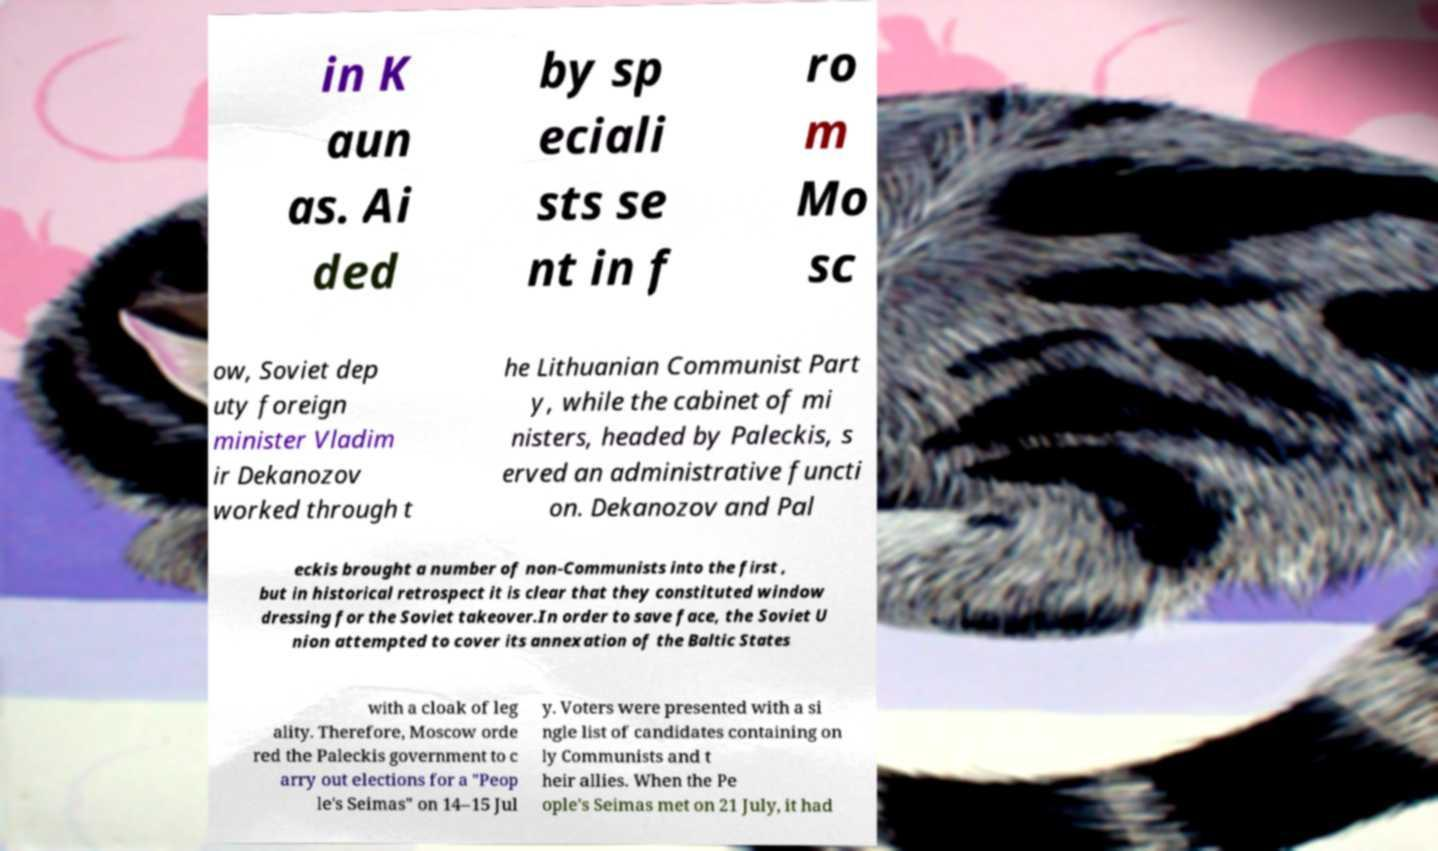I need the written content from this picture converted into text. Can you do that? in K aun as. Ai ded by sp eciali sts se nt in f ro m Mo sc ow, Soviet dep uty foreign minister Vladim ir Dekanozov worked through t he Lithuanian Communist Part y, while the cabinet of mi nisters, headed by Paleckis, s erved an administrative functi on. Dekanozov and Pal eckis brought a number of non-Communists into the first , but in historical retrospect it is clear that they constituted window dressing for the Soviet takeover.In order to save face, the Soviet U nion attempted to cover its annexation of the Baltic States with a cloak of leg ality. Therefore, Moscow orde red the Paleckis government to c arry out elections for a "Peop le's Seimas" on 14–15 Jul y. Voters were presented with a si ngle list of candidates containing on ly Communists and t heir allies. When the Pe ople's Seimas met on 21 July, it had 